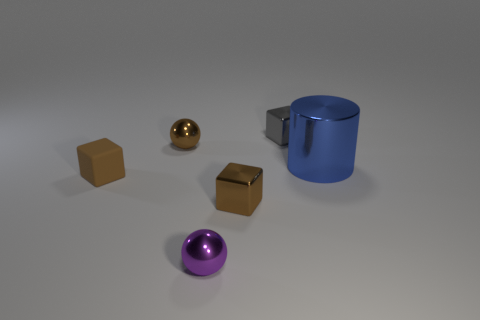What is the shape of the small gray object that is the same material as the blue object?
Ensure brevity in your answer.  Cube. Are there any other things of the same color as the large thing?
Provide a short and direct response. No. There is a small brown thing that is the same shape as the tiny purple object; what material is it?
Your answer should be compact. Metal. How many other things are there of the same size as the brown sphere?
Provide a succinct answer. 4. There is a ball that is the same color as the rubber block; what is its size?
Give a very brief answer. Small. There is a purple thing in front of the big shiny object; is it the same shape as the gray shiny object?
Keep it short and to the point. No. What number of other things are the same shape as the tiny gray thing?
Make the answer very short. 2. What shape is the metallic object left of the small purple shiny sphere?
Give a very brief answer. Sphere. Are there any tiny yellow balls that have the same material as the gray object?
Your response must be concise. No. There is a block behind the tiny brown matte object; is its color the same as the metal cylinder?
Your answer should be very brief. No. 